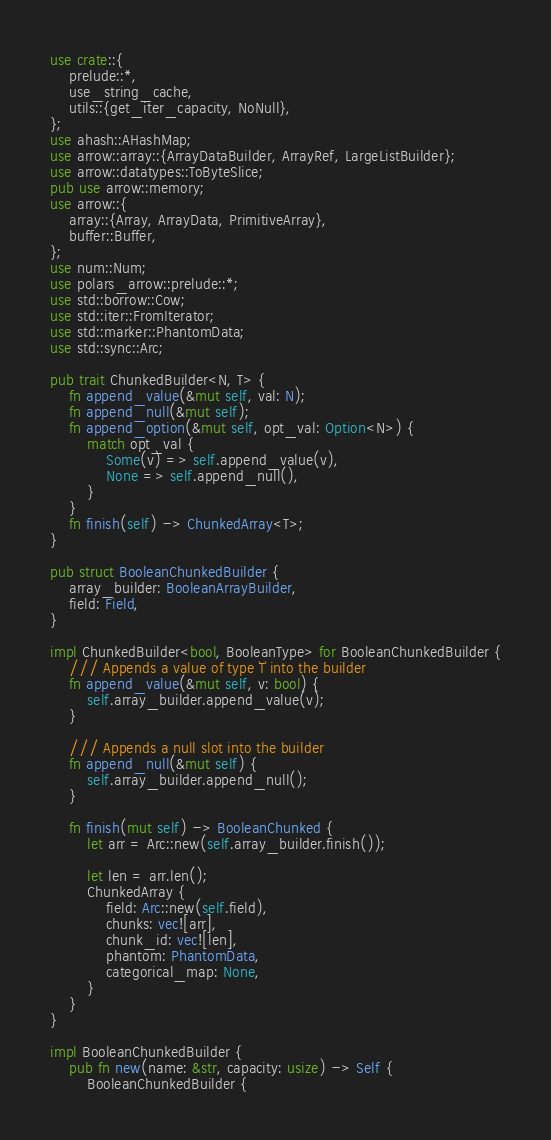<code> <loc_0><loc_0><loc_500><loc_500><_Rust_>use crate::{
    prelude::*,
    use_string_cache,
    utils::{get_iter_capacity, NoNull},
};
use ahash::AHashMap;
use arrow::array::{ArrayDataBuilder, ArrayRef, LargeListBuilder};
use arrow::datatypes::ToByteSlice;
pub use arrow::memory;
use arrow::{
    array::{Array, ArrayData, PrimitiveArray},
    buffer::Buffer,
};
use num::Num;
use polars_arrow::prelude::*;
use std::borrow::Cow;
use std::iter::FromIterator;
use std::marker::PhantomData;
use std::sync::Arc;

pub trait ChunkedBuilder<N, T> {
    fn append_value(&mut self, val: N);
    fn append_null(&mut self);
    fn append_option(&mut self, opt_val: Option<N>) {
        match opt_val {
            Some(v) => self.append_value(v),
            None => self.append_null(),
        }
    }
    fn finish(self) -> ChunkedArray<T>;
}

pub struct BooleanChunkedBuilder {
    array_builder: BooleanArrayBuilder,
    field: Field,
}

impl ChunkedBuilder<bool, BooleanType> for BooleanChunkedBuilder {
    /// Appends a value of type `T` into the builder
    fn append_value(&mut self, v: bool) {
        self.array_builder.append_value(v);
    }

    /// Appends a null slot into the builder
    fn append_null(&mut self) {
        self.array_builder.append_null();
    }

    fn finish(mut self) -> BooleanChunked {
        let arr = Arc::new(self.array_builder.finish());

        let len = arr.len();
        ChunkedArray {
            field: Arc::new(self.field),
            chunks: vec![arr],
            chunk_id: vec![len],
            phantom: PhantomData,
            categorical_map: None,
        }
    }
}

impl BooleanChunkedBuilder {
    pub fn new(name: &str, capacity: usize) -> Self {
        BooleanChunkedBuilder {</code> 